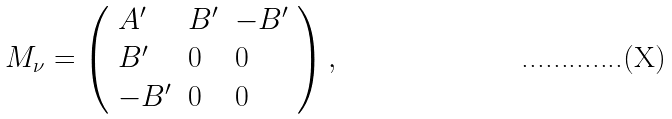<formula> <loc_0><loc_0><loc_500><loc_500>M _ { \nu } = \left ( \begin{array} { l l l } { { A ^ { \prime } } } & { { B ^ { \prime } } } & { { - B ^ { \prime } } } \\ { { B ^ { \prime } } } & { 0 } & { 0 } \\ { { - B ^ { \prime } } } & { 0 } & { 0 } \end{array} \right ) ,</formula> 